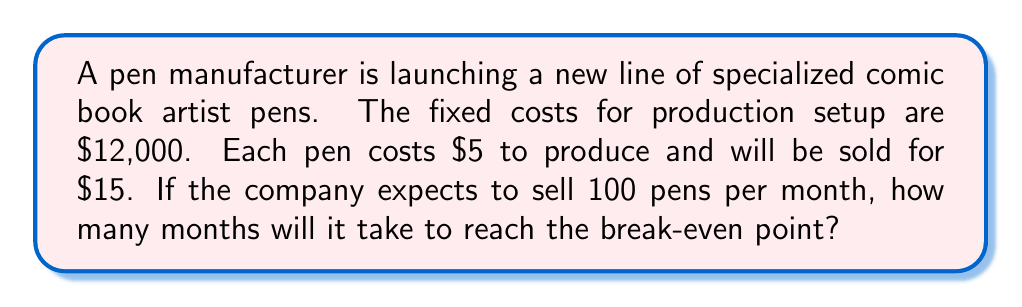Solve this math problem. To solve this problem, we need to calculate the break-even point, which is the point at which total revenue equals total costs. Let's break it down step-by-step:

1. Define variables:
   $FC$ = Fixed Costs
   $P$ = Price per unit
   $V$ = Variable Cost per unit
   $Q$ = Quantity sold
   $x$ = Number of months

2. Given information:
   $FC = \$12,000$
   $P = \$15$ per pen
   $V = \$5$ per pen
   $Q = 100$ pens per month

3. Calculate the contribution margin per unit:
   Contribution Margin = Price - Variable Cost
   $CM = P - V = \$15 - \$5 = \$10$ per pen

4. Set up the break-even equation:
   Total Revenue = Total Costs
   $PQ = FC + VQ$
   $15Q = 12,000 + 5Q$
   $10Q = 12,000$

5. Solve for Q (break-even quantity):
   $Q = \frac{12,000}{10} = 1,200$ pens

6. Calculate the number of months to reach break-even:
   Months to break-even = Break-even quantity ÷ Monthly sales
   $x = \frac{1,200}{100} = 12$ months

Therefore, it will take 12 months to reach the break-even point.
Answer: 12 months 